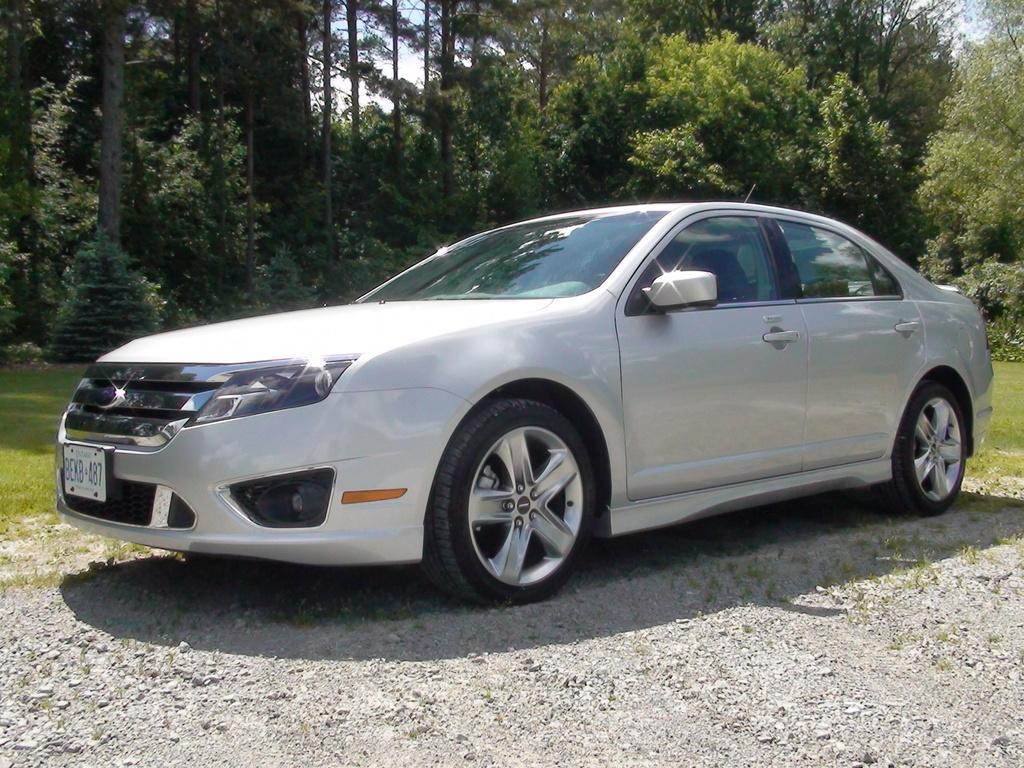How would you summarize this image in a sentence or two? In this image we can see a car that is placed on the ground. In the background we can see sky, trees and grass. 